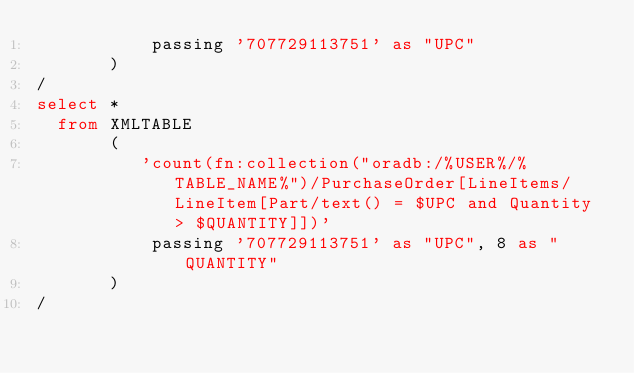<code> <loc_0><loc_0><loc_500><loc_500><_SQL_>           passing '707729113751' as "UPC"
       )
/
select * 
  from XMLTABLE
       (
          'count(fn:collection("oradb:/%USER%/%TABLE_NAME%")/PurchaseOrder[LineItems/LineItem[Part/text() = $UPC and Quantity > $QUANTITY]])'
           passing '707729113751' as "UPC", 8 as "QUANTITY"
       )
/</code> 